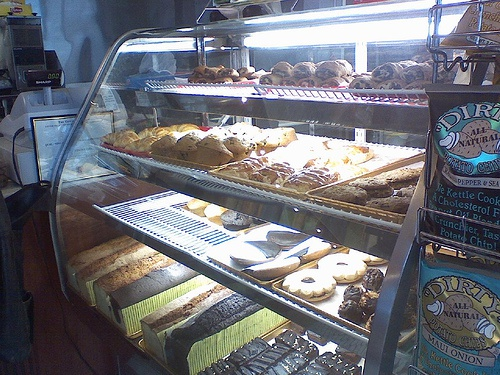Describe the objects in this image and their specific colors. I can see cake in gray, white, maroon, and black tones, cake in gray, black, olive, and khaki tones, cake in gray, darkgray, ivory, and black tones, cake in gray, maroon, and white tones, and cake in gray, white, and darkgray tones in this image. 